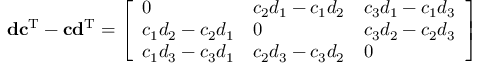Convert formula to latex. <formula><loc_0><loc_0><loc_500><loc_500>d c ^ { T } - c d ^ { T } = { \left [ \begin{array} { l l l } { 0 } & { c _ { 2 } d _ { 1 } - c _ { 1 } d _ { 2 } } & { c _ { 3 } d _ { 1 } - c _ { 1 } d _ { 3 } } \\ { c _ { 1 } d _ { 2 } - c _ { 2 } d _ { 1 } } & { 0 } & { c _ { 3 } d _ { 2 } - c _ { 2 } d _ { 3 } } \\ { c _ { 1 } d _ { 3 } - c _ { 3 } d _ { 1 } } & { c _ { 2 } d _ { 3 } - c _ { 3 } d _ { 2 } } & { 0 } \end{array} \right ] }</formula> 